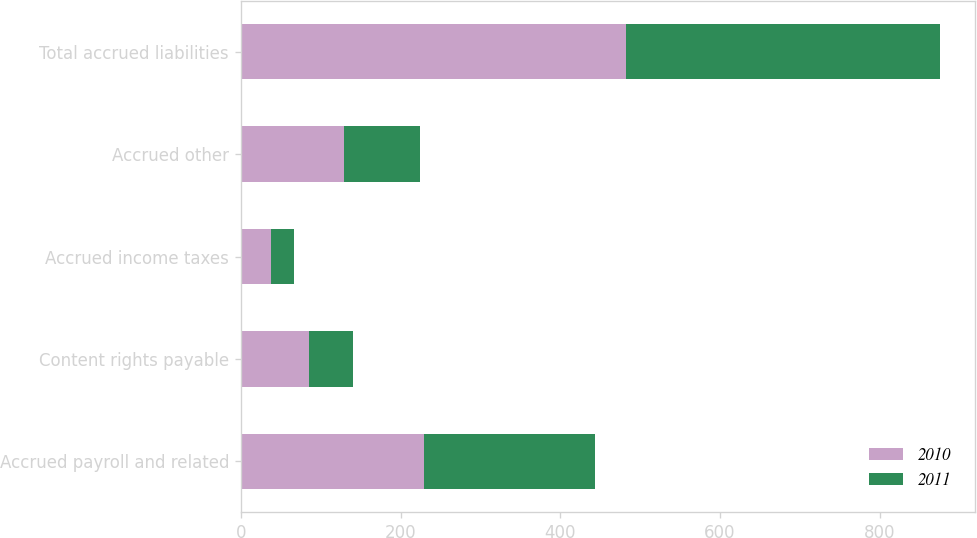<chart> <loc_0><loc_0><loc_500><loc_500><stacked_bar_chart><ecel><fcel>Accrued payroll and related<fcel>Content rights payable<fcel>Accrued income taxes<fcel>Accrued other<fcel>Total accrued liabilities<nl><fcel>2010<fcel>229<fcel>86<fcel>38<fcel>129<fcel>482<nl><fcel>2011<fcel>214<fcel>55<fcel>29<fcel>95<fcel>393<nl></chart> 